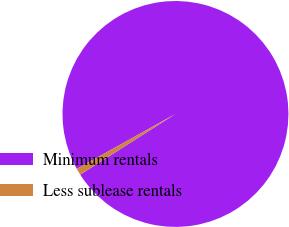<chart> <loc_0><loc_0><loc_500><loc_500><pie_chart><fcel>Minimum rentals<fcel>Less sublease rentals<nl><fcel>99.05%<fcel>0.95%<nl></chart> 